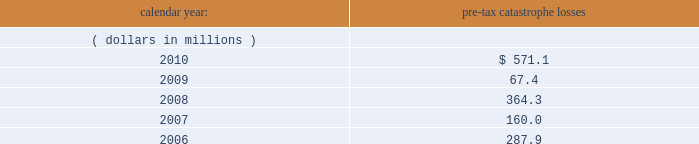United kingdom .
Bermuda re 2019s uk branch conducts business in the uk and is subject to taxation in the uk .
Bermuda re believes that it has operated and will continue to operate its bermuda operation in a manner which will not cause them to be subject to uk taxation .
If bermuda re 2019s bermuda operations were to become subject to uk income tax , there could be a material adverse impact on the company 2019s financial condition , results of operations and cash flow .
Ireland .
Holdings ireland and ireland re conduct business in ireland and are subject to taxation in ireland .
Available information .
The company 2019s annual reports on form 10-k , quarterly reports on form 10-q , current reports on form 8- k , proxy statements and amendments to those reports are available free of charge through the company 2019s internet website at http://www.everestre.com as soon as reasonably practicable after such reports are electronically filed with the securities and exchange commission ( the 201csec 201d ) .
Item 1a .
Risk factors in addition to the other information provided in this report , the following risk factors should be considered when evaluating an investment in our securities .
If the circumstances contemplated by the individual risk factors materialize , our business , financial condition and results of operations could be materially and adversely affected and the trading price of our common shares could decline significantly .
Risks relating to our business fluctuations in the financial markets could result in investment losses .
Prolonged and severe disruptions in the public debt and equity markets , such as occurred during 2008 , could result in significant realized and unrealized losses in our investment portfolio .
For the year ended december 31 , 2008 , we incurred $ 695.8 million of realized investment gains and $ 310.4 million of unrealized investment losses .
Although financial markets significantly improved during 2009 and 2010 , they could deteriorate in the future and again result in substantial realized and unrealized losses , which could have a material adverse impact on our results of operations , equity , business and insurer financial strength and debt ratings .
Our results could be adversely affected by catastrophic events .
We are exposed to unpredictable catastrophic events , including weather-related and other natural catastrophes , as well as acts of terrorism .
Any material reduction in our operating results caused by the occurrence of one or more catastrophes could inhibit our ability to pay dividends or to meet our interest and principal payment obligations .
Subsequent to april 1 , 2010 , we define a catastrophe as an event that causes a loss on property exposures before reinsurance of at least $ 10.0 million , before corporate level reinsurance and taxes .
Prior to april 1 , 2010 , we used a threshold of $ 5.0 million .
By way of illustration , during the past five calendar years , pre-tax catastrophe losses , net of contract specific reinsurance but before cessions under corporate reinsurance programs , were as follows: .

What would be the net value , in millions of dollars , of investment gains in 2008 if all unrealized losses were realized? 
Rationale: i am not actually sure how relevant this question is . gains or losses are said to be "realized" when a stock ( or other investment ) that you own is actually sold . unrealized gains and losses are also commonly known as "paper" profits or losses . an unrealized loss occurs when a stock decreases after an investor buys it , but has yet to sell it .
Computations: (695.8 - 310.4)
Answer: 385.4. 